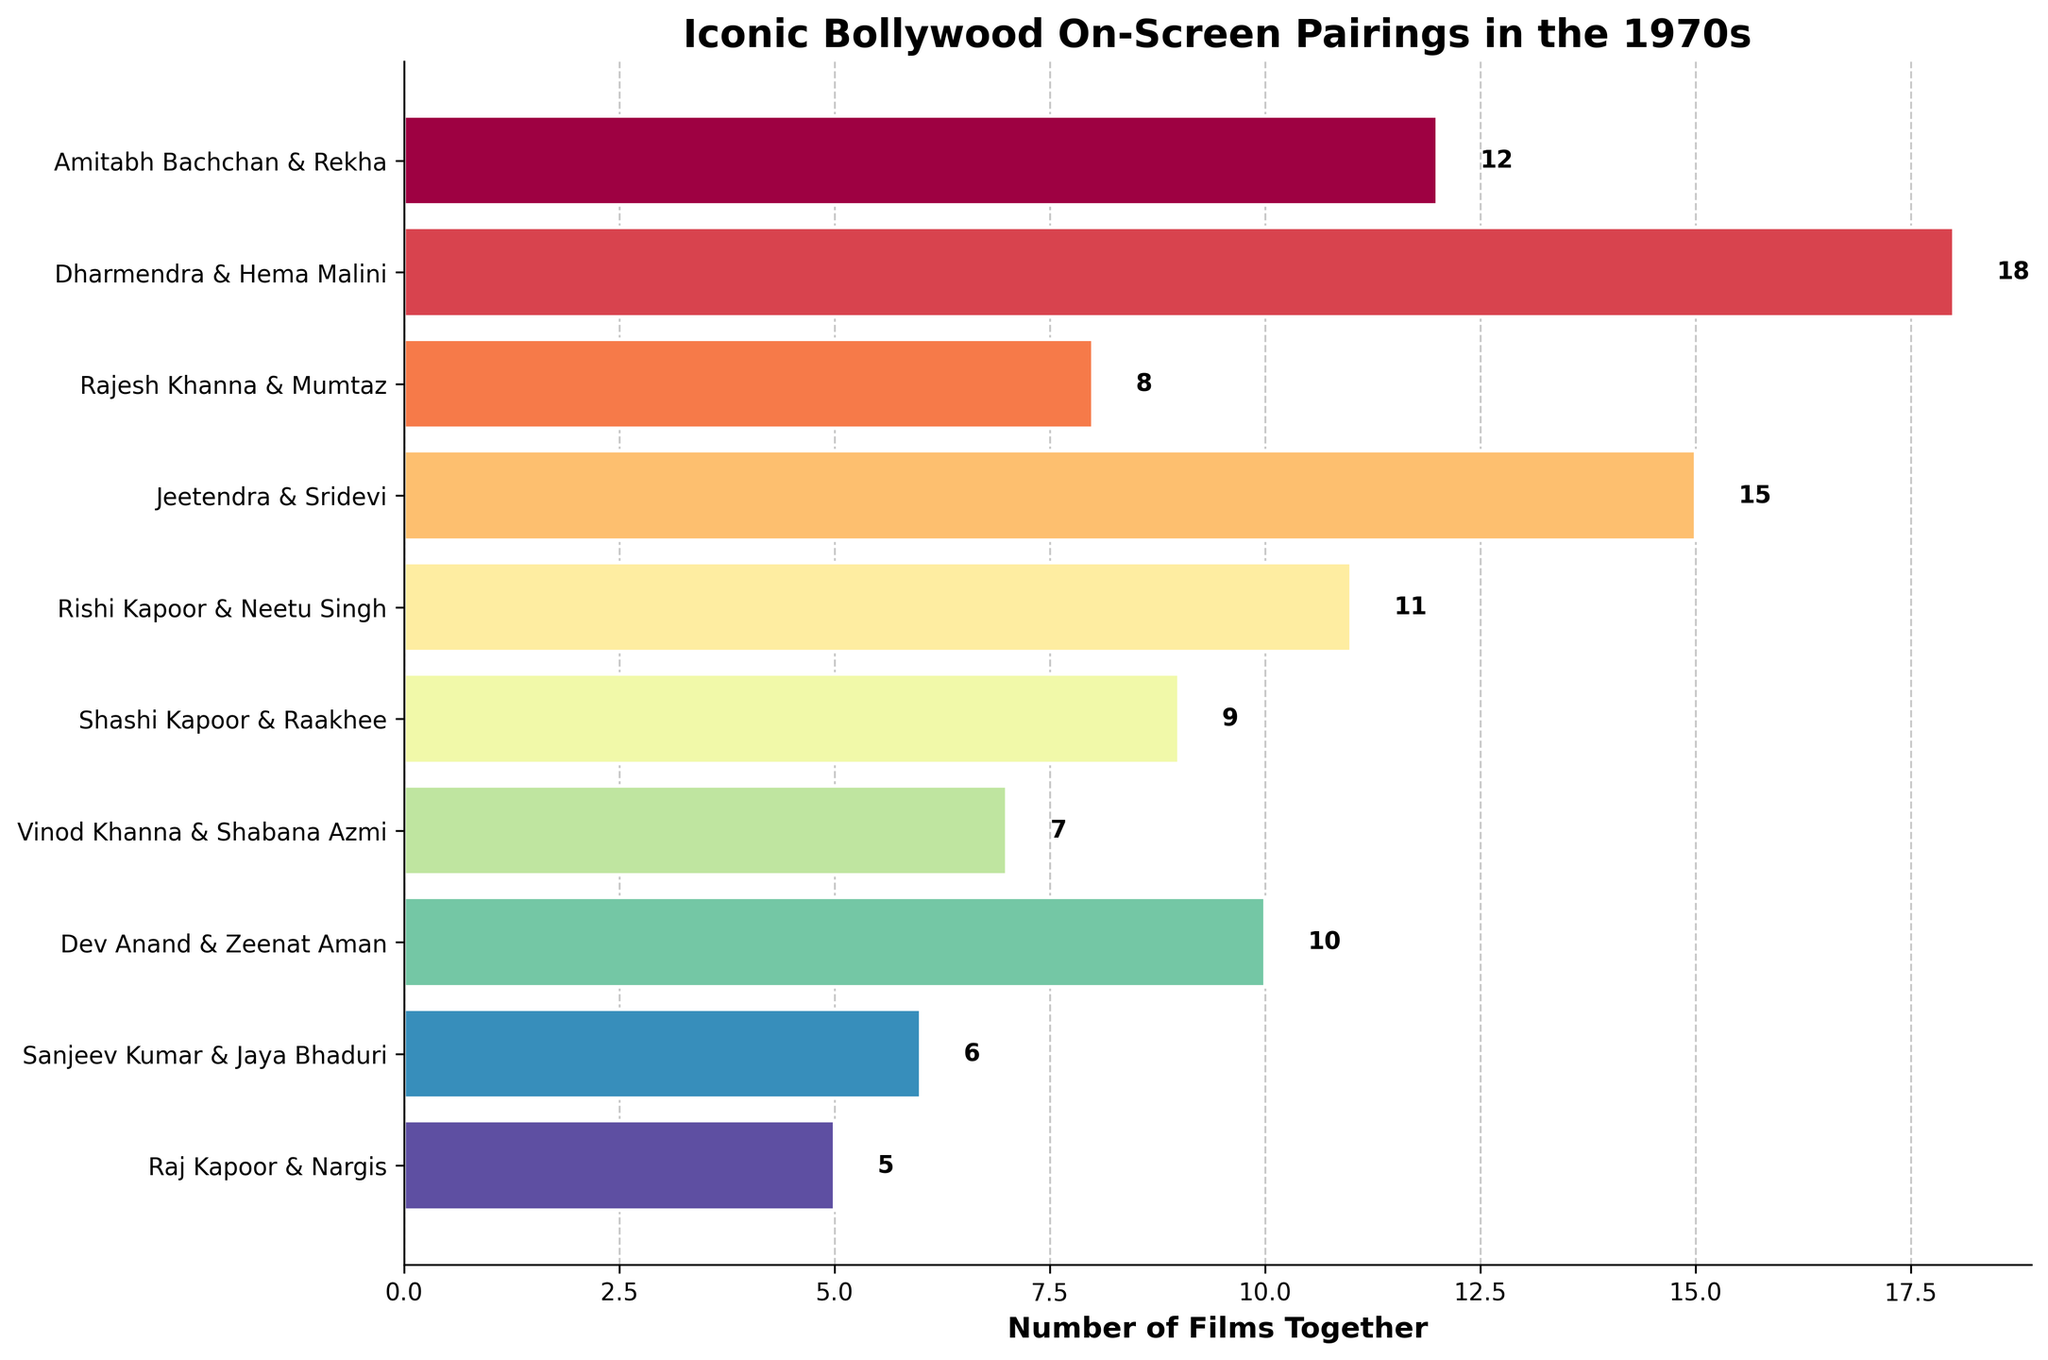Which actor pair has the highest number of films together? By examining the lengths of all the bars in the figure, the bar representing Dharmendra & Hema Malini is the longest, indicating they have the highest number of films together.
Answer: Dharmendra & Hema Malini Which actor pair has the lowest number of films together? Among all the bars, the one representing Raj Kapoor & Nargis is the shortest, indicating they have the lowest number of films together.
Answer: Raj Kapoor & Nargis How many more films did Jeetendra & Sridevi feature in together compared to Rajesh Khanna & Mumtaz? From the figure, Jeetendra & Sridevi featured in 15 films, and Rajesh Khanna & Mumtaz featured in 8 films. The difference is 15 - 8 = 7.
Answer: 7 What’s the total number of films Amitabh Bachchan & Rekha and Vinod Khanna & Shabana Azmi featured in together? Amitabh Bachchan & Rekha featured in 12 films, and Vinod Khanna & Shabana Azmi featured in 7 films. The total is 12 + 7 = 19.
Answer: 19 What's the average number of films that the actor pairs featured in together? Summing up the number of films together for all pairs gives (12 + 18 + 8 + 15 + 11 + 9 + 7 + 10 + 6 + 5) = 101. There are 10 pairs, so the average is 101 / 10 = 10.1.
Answer: 10.1 Which actor pair has the median number of films together? When the numbers of films are ordered, the pairs are (5, 6, 7, 8, 9, 10, 11, 12, 15, 18). The median value falls between the 5th and 6th values, which are 9 and 10. The median actor pair is therefore Shashi Kapoor & Raakhee and Dev Anand & Zeenat Aman.
Answer: Shashi Kapoor & Raakhee and Dev Anand & Zeenat Aman How many pairs featured in more than 10 films together? By counting the bars representing more than 10 films, the pairs are Amitabh Bachchan & Rekha, Dharmendra & Hema Malini, Jeetendra & Sridevi, and Rishi Kapoor & Neetu Singh. There are 4 pairs.
Answer: 4 